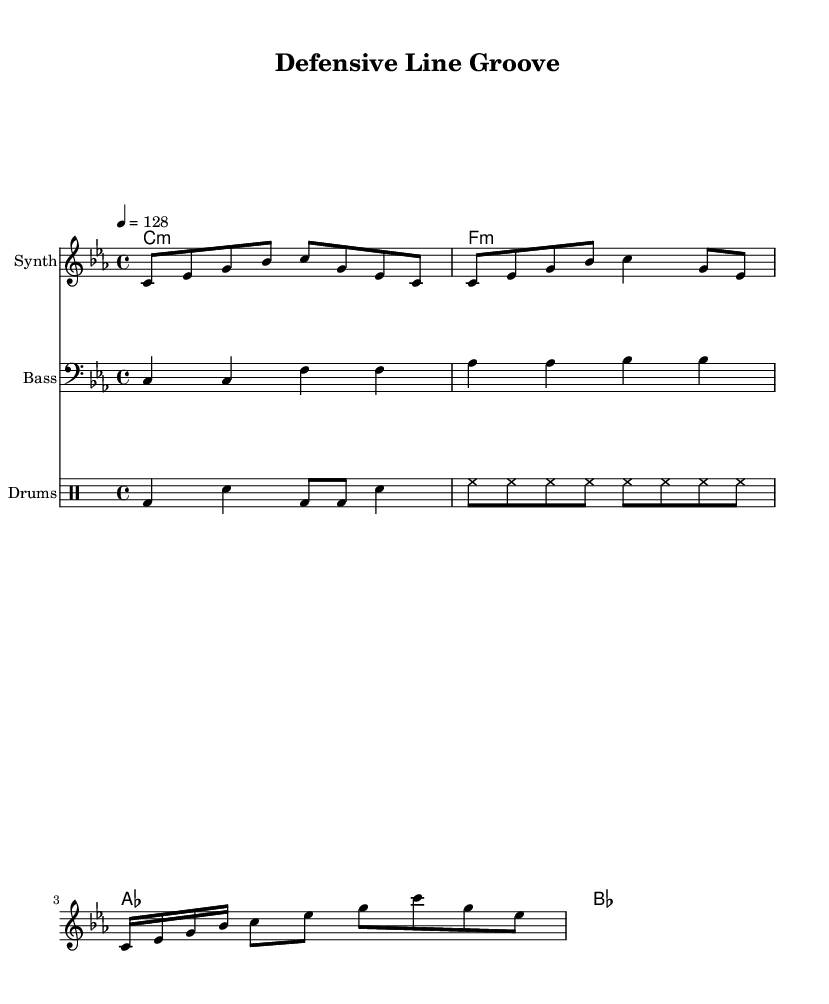What is the key signature of this music? The key signature is indicated by the key signature on the left side of the staff. In this case, it shows three flats, which corresponds to C minor.
Answer: C minor What is the time signature of this music? The time signature is shown at the beginning after the key signature. Here, it is indicated as 4/4, meaning there are four beats in each measure.
Answer: 4/4 What is the tempo marking for this piece? The tempo marking is found at the beginning and specifies the speed of the music. It shows "4 = 128", which means there are 128 beats per minute at a quarter note.
Answer: 128 How many measures are in the synth melody? The synth melody is broken down into measures, and by counting the vertical lines (bar lines), we can determine the total. There are a total of 4 measures in the synth melody.
Answer: 4 What kind of rhythm does the drum pattern use? The drum pattern is displayed using drummode notation, showing that it incorporates kick drums (bd), snare drums (sn), and hi-hats (hh). This results in a standard four-on-the-floor rhythm typical in dance music.
Answer: Four-on-the-floor What is the structure of the chord progression in this piece? The chords are written above the staffs and show a sequence that includes four different chords: C minor, F minor, A flat, and B flat. Observing their order indicates a structure based on these four chords played throughout the piece.
Answer: C minor, F minor, A flat, B flat What instrument is the bass line written for? The bass line is notated on a staff that indicates it is for a bass instrument, as denoted by the clef symbol placed at the beginning of the bass staff, specifically referring to the bass clef used for lower pitches.
Answer: Bass 